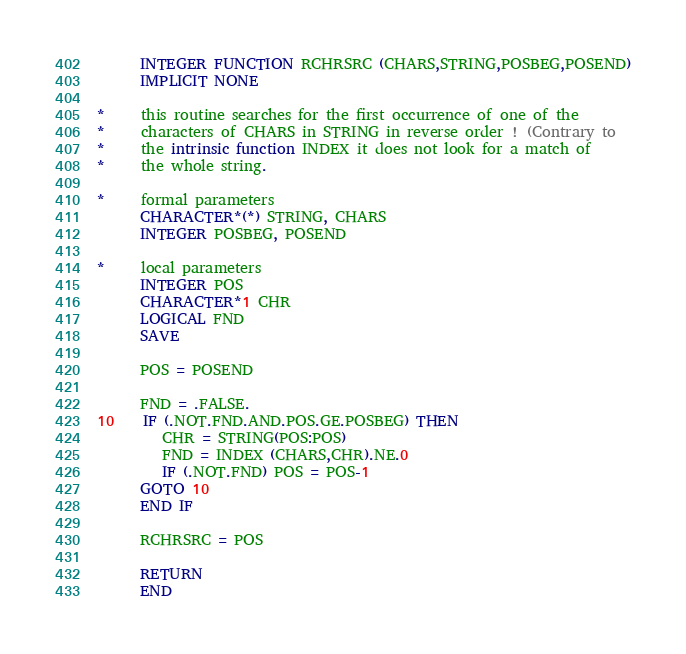<code> <loc_0><loc_0><loc_500><loc_500><_FORTRAN_>      INTEGER FUNCTION RCHRSRC (CHARS,STRING,POSBEG,POSEND)
      IMPLICIT NONE

*     this routine searches for the first occurrence of one of the
*     characters of CHARS in STRING in reverse order ! (Contrary to
*     the intrinsic function INDEX it does not look for a match of
*     the whole string.

*     formal parameters
      CHARACTER*(*) STRING, CHARS
      INTEGER POSBEG, POSEND

*     local parameters
      INTEGER POS
      CHARACTER*1 CHR
      LOGICAL FND
      SAVE

      POS = POSEND

      FND = .FALSE.
10    IF (.NOT.FND.AND.POS.GE.POSBEG) THEN
         CHR = STRING(POS:POS)
         FND = INDEX (CHARS,CHR).NE.0
         IF (.NOT.FND) POS = POS-1
      GOTO 10
      END IF

      RCHRSRC = POS

      RETURN
      END
</code> 